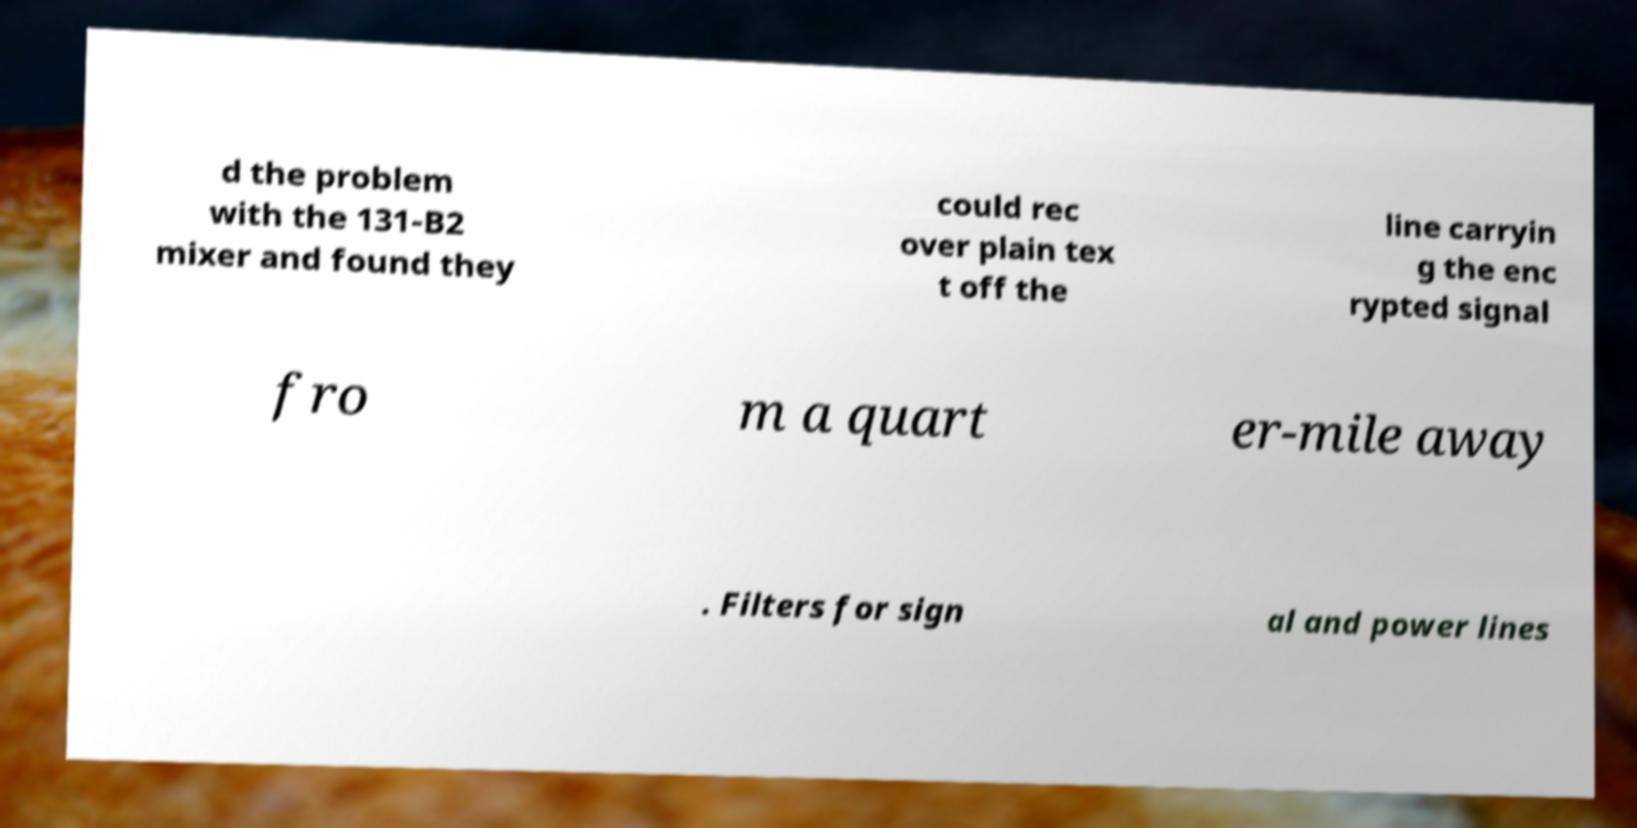There's text embedded in this image that I need extracted. Can you transcribe it verbatim? d the problem with the 131-B2 mixer and found they could rec over plain tex t off the line carryin g the enc rypted signal fro m a quart er-mile away . Filters for sign al and power lines 